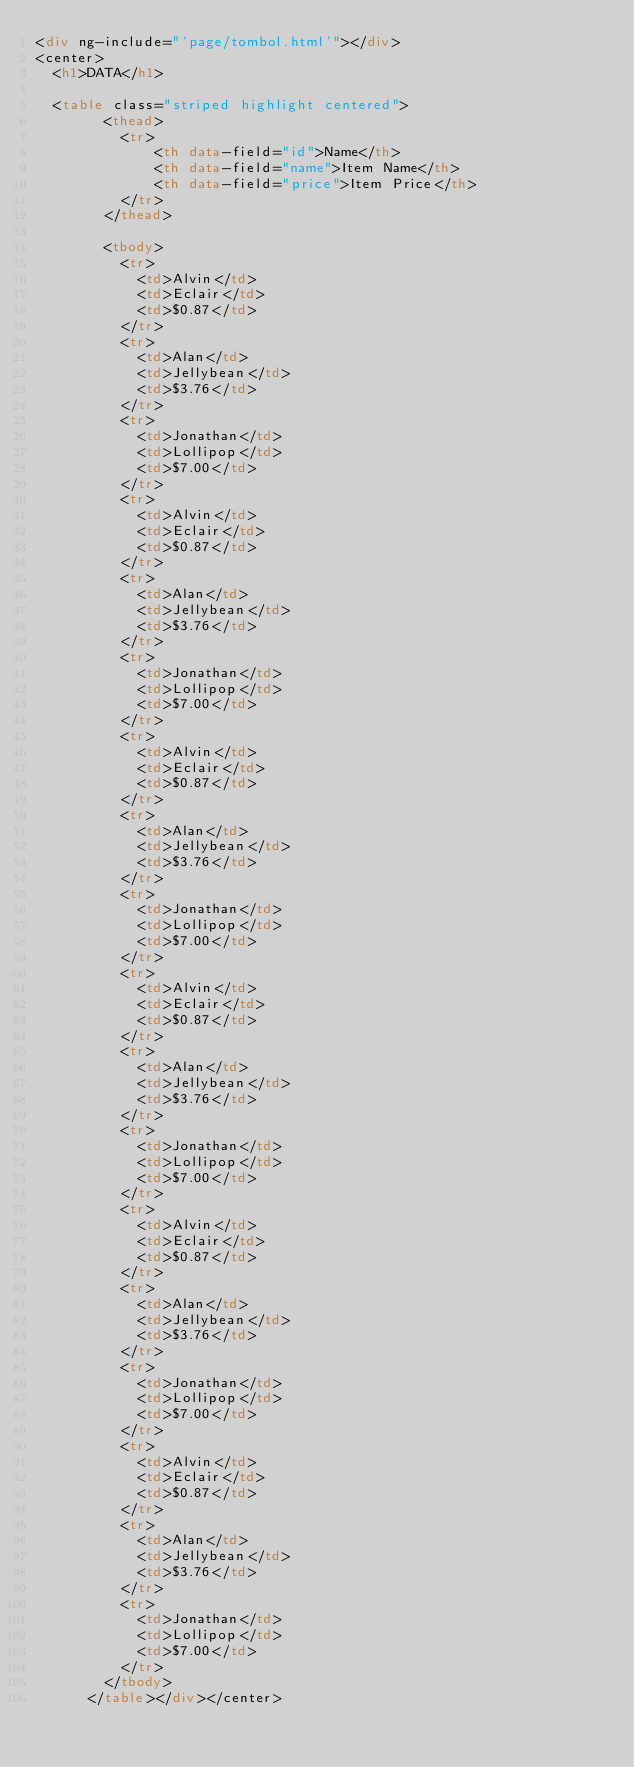Convert code to text. <code><loc_0><loc_0><loc_500><loc_500><_HTML_><div ng-include="'page/tombol.html'"></div>
<center>
  <h1>DATA</h1>

  <table class="striped highlight centered">
        <thead>
          <tr>
              <th data-field="id">Name</th>
              <th data-field="name">Item Name</th>
              <th data-field="price">Item Price</th>
          </tr>
        </thead>

        <tbody>
          <tr>
            <td>Alvin</td>
            <td>Eclair</td>
            <td>$0.87</td>
          </tr>
          <tr>
            <td>Alan</td>
            <td>Jellybean</td>
            <td>$3.76</td>
          </tr>
          <tr>
            <td>Jonathan</td>
            <td>Lollipop</td>
            <td>$7.00</td>
          </tr>
          <tr>
            <td>Alvin</td>
            <td>Eclair</td>
            <td>$0.87</td>
          </tr>
          <tr>
            <td>Alan</td>
            <td>Jellybean</td>
            <td>$3.76</td>
          </tr>
          <tr>
            <td>Jonathan</td>
            <td>Lollipop</td>
            <td>$7.00</td>
          </tr>
          <tr>
            <td>Alvin</td>
            <td>Eclair</td>
            <td>$0.87</td>
          </tr>
          <tr>
            <td>Alan</td>
            <td>Jellybean</td>
            <td>$3.76</td>
          </tr>
          <tr>
            <td>Jonathan</td>
            <td>Lollipop</td>
            <td>$7.00</td>
          </tr>
          <tr>
            <td>Alvin</td>
            <td>Eclair</td>
            <td>$0.87</td>
          </tr>
          <tr>
            <td>Alan</td>
            <td>Jellybean</td>
            <td>$3.76</td>
          </tr>
          <tr>
            <td>Jonathan</td>
            <td>Lollipop</td>
            <td>$7.00</td>
          </tr>
          <tr>
            <td>Alvin</td>
            <td>Eclair</td>
            <td>$0.87</td>
          </tr>
          <tr>
            <td>Alan</td>
            <td>Jellybean</td>
            <td>$3.76</td>
          </tr>
          <tr>
            <td>Jonathan</td>
            <td>Lollipop</td>
            <td>$7.00</td>
          </tr>
          <tr>
            <td>Alvin</td>
            <td>Eclair</td>
            <td>$0.87</td>
          </tr>
          <tr>
            <td>Alan</td>
            <td>Jellybean</td>
            <td>$3.76</td>
          </tr>
          <tr>
            <td>Jonathan</td>
            <td>Lollipop</td>
            <td>$7.00</td>
          </tr>
        </tbody>
      </table></div></center></code> 